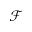Convert formula to latex. <formula><loc_0><loc_0><loc_500><loc_500>\mathcal { F }</formula> 